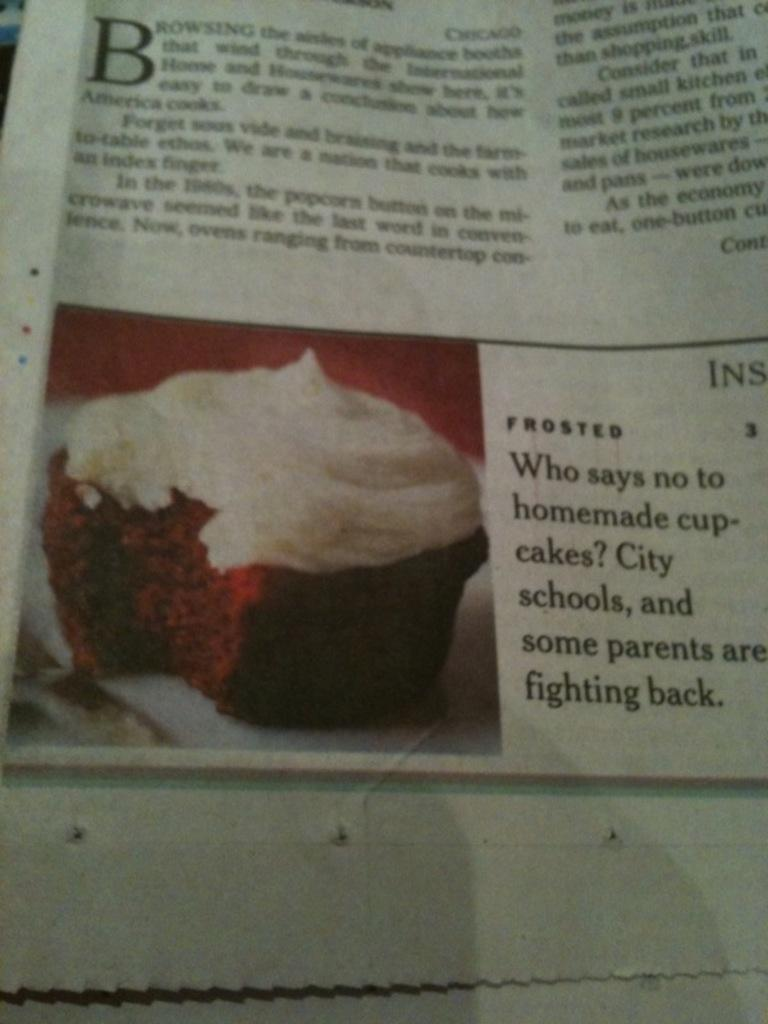<image>
Describe the image concisely. A newspaper article claims that schools and some parents do not like cupcakes. 